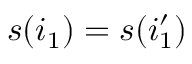Convert formula to latex. <formula><loc_0><loc_0><loc_500><loc_500>s ( i _ { 1 } ) = s ( i _ { 1 } ^ { \prime } )</formula> 